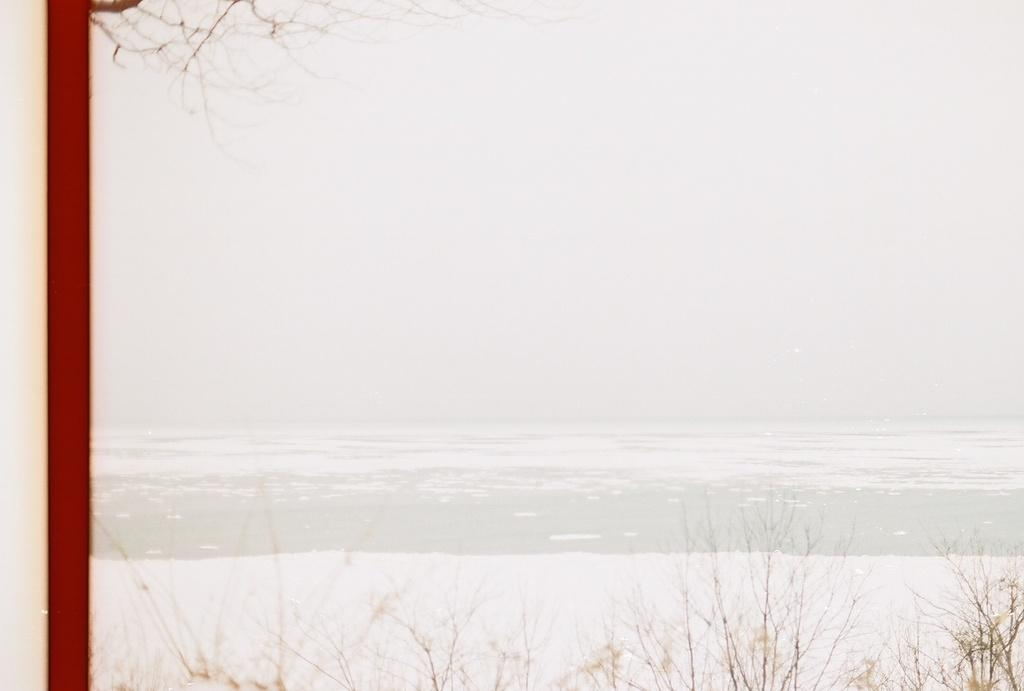What type of living organisms can be seen in the image? Plants can be seen in the image. What is the primary element visible in the image? Water is visible in the image. Where is the pole located in the image? The pole is on the left side of the image. What is the profit made by the plants in the image? There is no indication of profit in the image, as plants do not generate profit. 